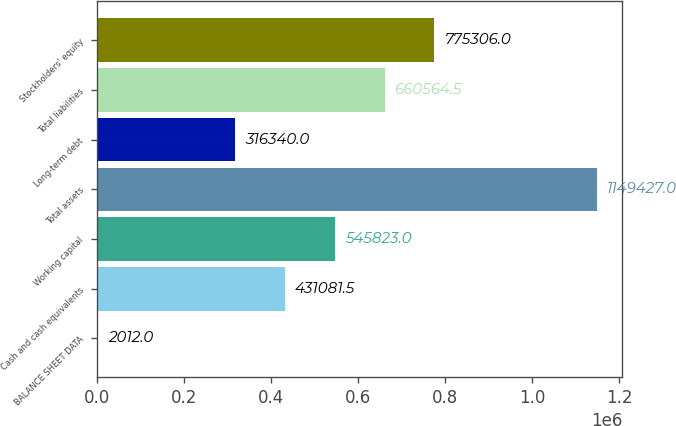Convert chart. <chart><loc_0><loc_0><loc_500><loc_500><bar_chart><fcel>BALANCE SHEET DATA<fcel>Cash and cash equivalents<fcel>Working capital<fcel>Total assets<fcel>Long-term debt<fcel>Total liabilities<fcel>Stockholders' equity<nl><fcel>2012<fcel>431082<fcel>545823<fcel>1.14943e+06<fcel>316340<fcel>660564<fcel>775306<nl></chart> 